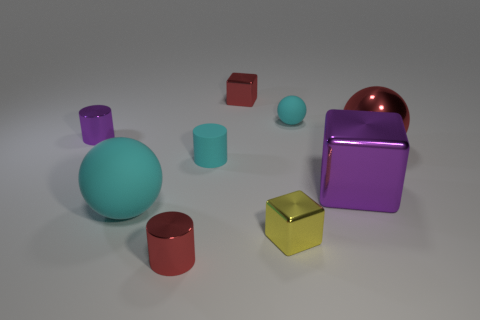What is the material of the red cylinder that is to the left of the small metal block behind the tiny cyan rubber cylinder?
Ensure brevity in your answer.  Metal. What is the shape of the tiny matte object that is the same color as the small matte ball?
Your answer should be compact. Cylinder. Are there any cyan blocks made of the same material as the large cyan sphere?
Make the answer very short. No. Does the large cyan ball have the same material as the small red thing behind the large metal sphere?
Make the answer very short. No. The metallic cube that is the same size as the red ball is what color?
Provide a short and direct response. Purple. How big is the cylinder that is behind the red shiny thing right of the tiny yellow thing?
Offer a very short reply. Small. There is a tiny rubber sphere; does it have the same color as the big shiny thing in front of the large red thing?
Your answer should be compact. No. Is the number of yellow metal cubes that are behind the tiny cyan cylinder less than the number of red shiny cubes?
Give a very brief answer. Yes. What number of other things are the same size as the yellow metal cube?
Offer a very short reply. 5. There is a tiny rubber thing that is on the right side of the small red metallic cube; does it have the same shape as the large cyan object?
Offer a terse response. Yes. 